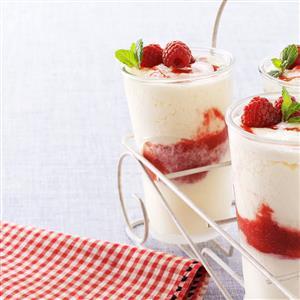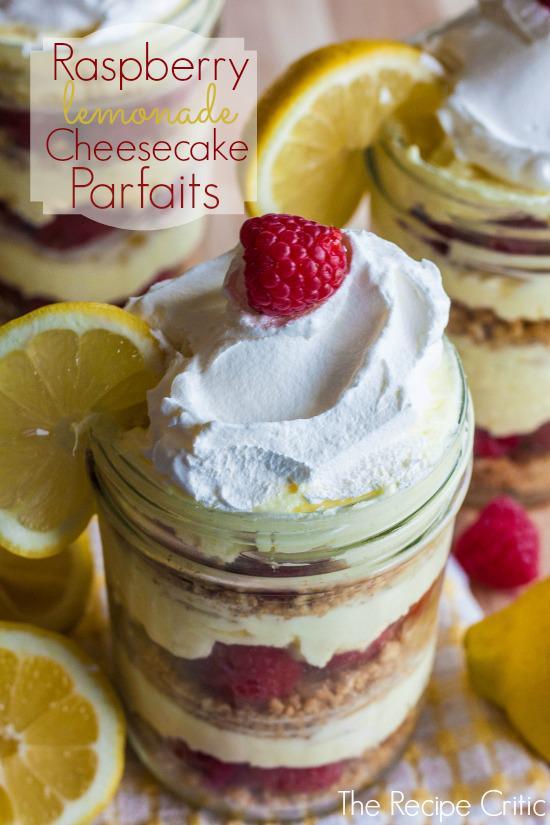The first image is the image on the left, the second image is the image on the right. Given the left and right images, does the statement "There are lemon slices on top of a trifle in one of the images." hold true? Answer yes or no. Yes. The first image is the image on the left, the second image is the image on the right. Evaluate the accuracy of this statement regarding the images: "At least one image shows individual servings of layered dessert in non-footed glasses garnished with raspberries.". Is it true? Answer yes or no. Yes. 